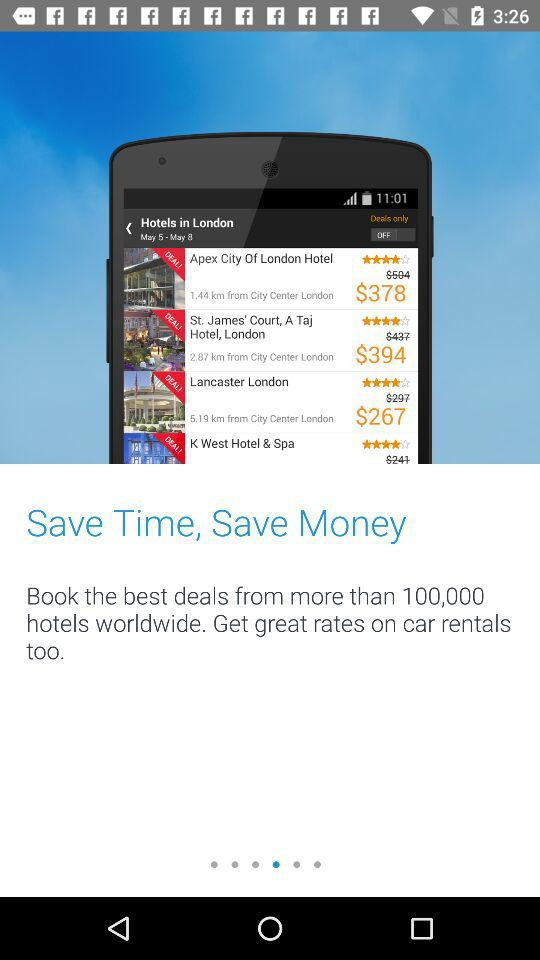How many hotels throughout the world can book the best deal? We can book the best deals from more than 100,000 hotels. 